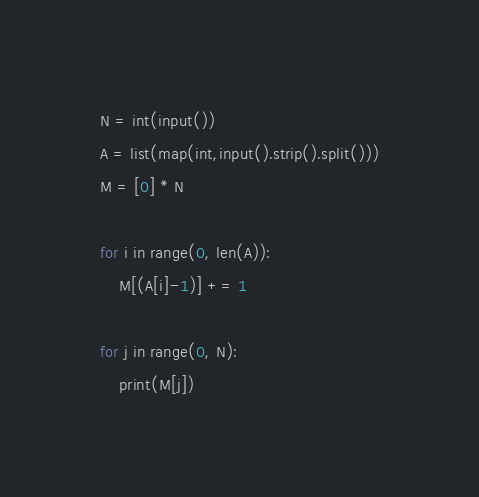<code> <loc_0><loc_0><loc_500><loc_500><_Python_>N = int(input())
A = list(map(int,input().strip().split()))
M = [0] * N
 
for i in range(0, len(A)):
    M[(A[i]-1)] += 1
 
for j in range(0, N):
    print(M[j])
</code> 